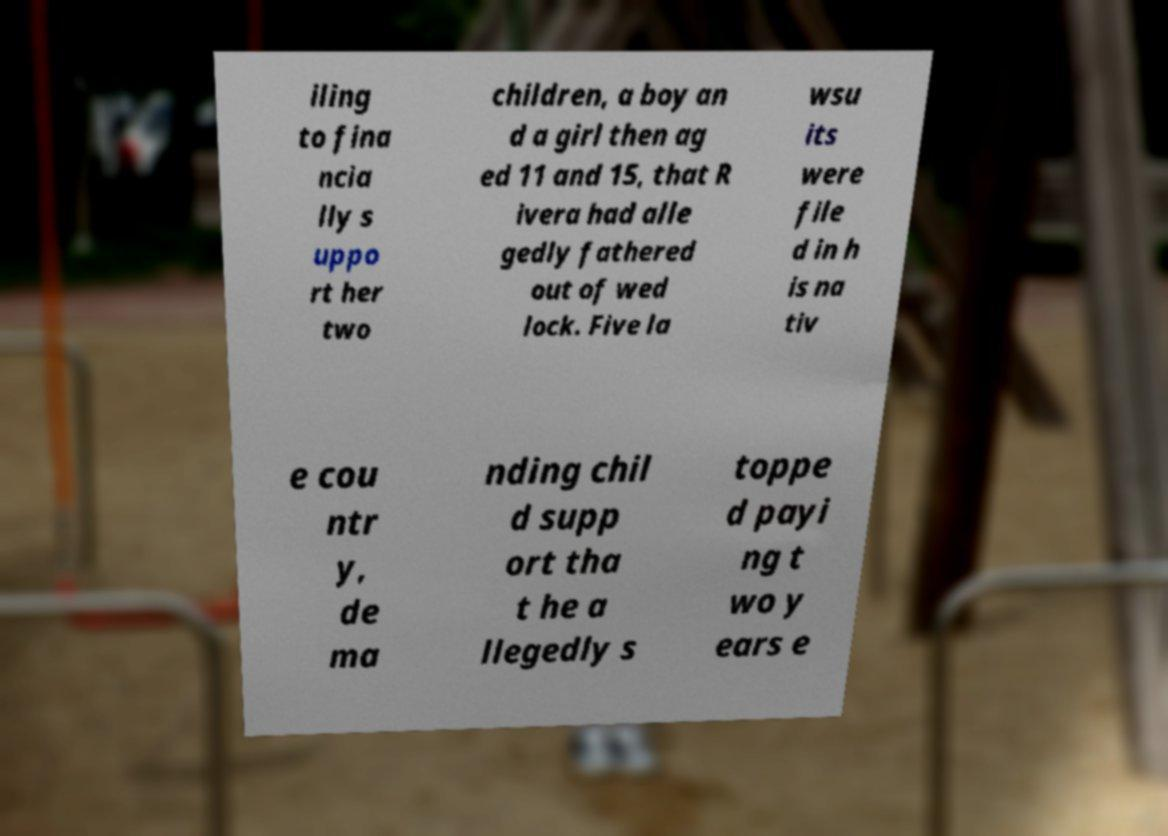Could you assist in decoding the text presented in this image and type it out clearly? iling to fina ncia lly s uppo rt her two children, a boy an d a girl then ag ed 11 and 15, that R ivera had alle gedly fathered out of wed lock. Five la wsu its were file d in h is na tiv e cou ntr y, de ma nding chil d supp ort tha t he a llegedly s toppe d payi ng t wo y ears e 